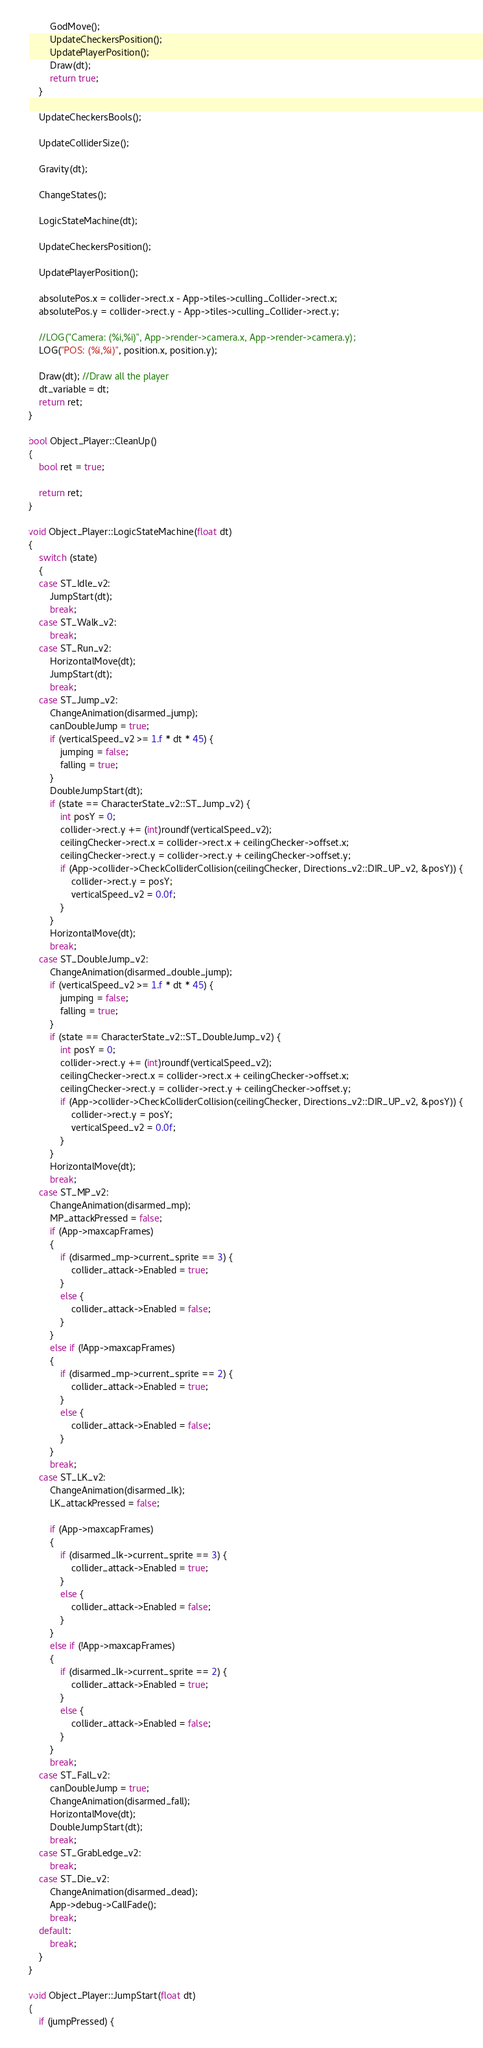<code> <loc_0><loc_0><loc_500><loc_500><_C++_>		GodMove();
		UpdateCheckersPosition();
		UpdatePlayerPosition();
		Draw(dt);
		return true;
	}

	UpdateCheckersBools();

	UpdateColliderSize();

	Gravity(dt);

	ChangeStates();

	LogicStateMachine(dt);

	UpdateCheckersPosition();

	UpdatePlayerPosition();

	absolutePos.x = collider->rect.x - App->tiles->culling_Collider->rect.x;
	absolutePos.y = collider->rect.y - App->tiles->culling_Collider->rect.y;

	//LOG("Camera: (%i,%i)", App->render->camera.x, App->render->camera.y);
	LOG("POS: (%i,%i)", position.x, position.y);

	Draw(dt); //Draw all the player
	dt_variable = dt;
	return ret;
}

bool Object_Player::CleanUp()
{
	bool ret = true;

	return ret;
}

void Object_Player::LogicStateMachine(float dt)
{
	switch (state)
	{
	case ST_Idle_v2:
		JumpStart(dt);
		break;
	case ST_Walk_v2:
		break;
	case ST_Run_v2:
		HorizontalMove(dt);
		JumpStart(dt);
		break;
	case ST_Jump_v2:
		ChangeAnimation(disarmed_jump);
		canDoubleJump = true;
		if (verticalSpeed_v2 >= 1.f * dt * 45) {
			jumping = false;
			falling = true;
		}
		DoubleJumpStart(dt);
		if (state == CharacterState_v2::ST_Jump_v2) {
			int posY = 0;
			collider->rect.y += (int)roundf(verticalSpeed_v2);
			ceilingChecker->rect.x = collider->rect.x + ceilingChecker->offset.x;
			ceilingChecker->rect.y = collider->rect.y + ceilingChecker->offset.y;
			if (App->collider->CheckColliderCollision(ceilingChecker, Directions_v2::DIR_UP_v2, &posY)) {
				collider->rect.y = posY;
				verticalSpeed_v2 = 0.0f;
			}
		}
		HorizontalMove(dt);
		break;
	case ST_DoubleJump_v2:
		ChangeAnimation(disarmed_double_jump);
		if (verticalSpeed_v2 >= 1.f * dt * 45) {
			jumping = false;
			falling = true;
		}
		if (state == CharacterState_v2::ST_DoubleJump_v2) {
			int posY = 0;
			collider->rect.y += (int)roundf(verticalSpeed_v2);
			ceilingChecker->rect.x = collider->rect.x + ceilingChecker->offset.x;
			ceilingChecker->rect.y = collider->rect.y + ceilingChecker->offset.y;
			if (App->collider->CheckColliderCollision(ceilingChecker, Directions_v2::DIR_UP_v2, &posY)) {
				collider->rect.y = posY;
				verticalSpeed_v2 = 0.0f;
			}
		}
		HorizontalMove(dt);
		break;
	case ST_MP_v2:
		ChangeAnimation(disarmed_mp);
		MP_attackPressed = false;
		if (App->maxcapFrames)
		{
			if (disarmed_mp->current_sprite == 3) {
				collider_attack->Enabled = true;
			}
			else {
				collider_attack->Enabled = false;
			}
		}
		else if (!App->maxcapFrames)
		{
			if (disarmed_mp->current_sprite == 2) {
				collider_attack->Enabled = true;
			}
			else {
				collider_attack->Enabled = false;
			}
		}
		break;
	case ST_LK_v2:
		ChangeAnimation(disarmed_lk);
		LK_attackPressed = false;

		if (App->maxcapFrames)
		{
			if (disarmed_lk->current_sprite == 3) {
				collider_attack->Enabled = true;
			}
			else {
				collider_attack->Enabled = false;
			}
		}
		else if (!App->maxcapFrames)
		{
			if (disarmed_lk->current_sprite == 2) {
				collider_attack->Enabled = true;
			}
			else {
				collider_attack->Enabled = false;
			}
		}
		break;
	case ST_Fall_v2:
		canDoubleJump = true;
		ChangeAnimation(disarmed_fall);
		HorizontalMove(dt);
		DoubleJumpStart(dt);
		break;
	case ST_GrabLedge_v2:
		break;
	case ST_Die_v2:
		ChangeAnimation(disarmed_dead);
		App->debug->CallFade();
		break;
	default:
		break;
	}
}

void Object_Player::JumpStart(float dt)
{
	if (jumpPressed) {</code> 